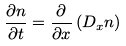<formula> <loc_0><loc_0><loc_500><loc_500>\frac { \partial n } { \partial t } = \frac { \partial } { \partial { x } } \left ( D _ { x } n \right )</formula> 